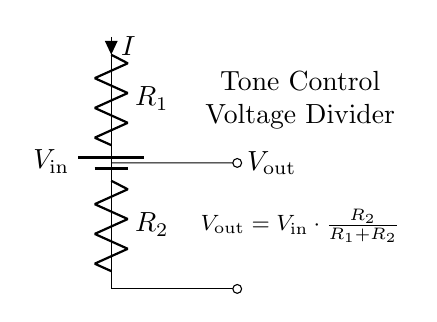What is the purpose of this circuit? The circuit is a voltage divider, specifically designed to adjust tone control in an audio system by providing a specific output voltage based on the input voltage and the resistor values.
Answer: tone control What are the two resistors in this circuit called? The resistors in the circuit are labeled as R1 and R2. They are essential components that determine the output voltage based on their values.
Answer: R1 and R2 What is the output voltage formula for this circuit? The output voltage is determined by the formula V out equals V in multiplied by the ratio of R2 to the sum of R1 and R2. The equation shows how the output voltage depends on the resistor values and the input voltage.
Answer: V out equals V in multiplied by R2 over R1 plus R2 Which resistor affects the tone more if increased? Increasing R2 will enhance the tone control effect, as it directly influences the output voltage while maintaining the same input voltage.
Answer: R2 What is the direction of current flow in this circuit? The current flows from the positive terminal of the input voltage source through R1, then R2, and back to the negative terminal. The direction is indicated by the arrow on the current label.
Answer: from V in through R1 and R2 to ground 